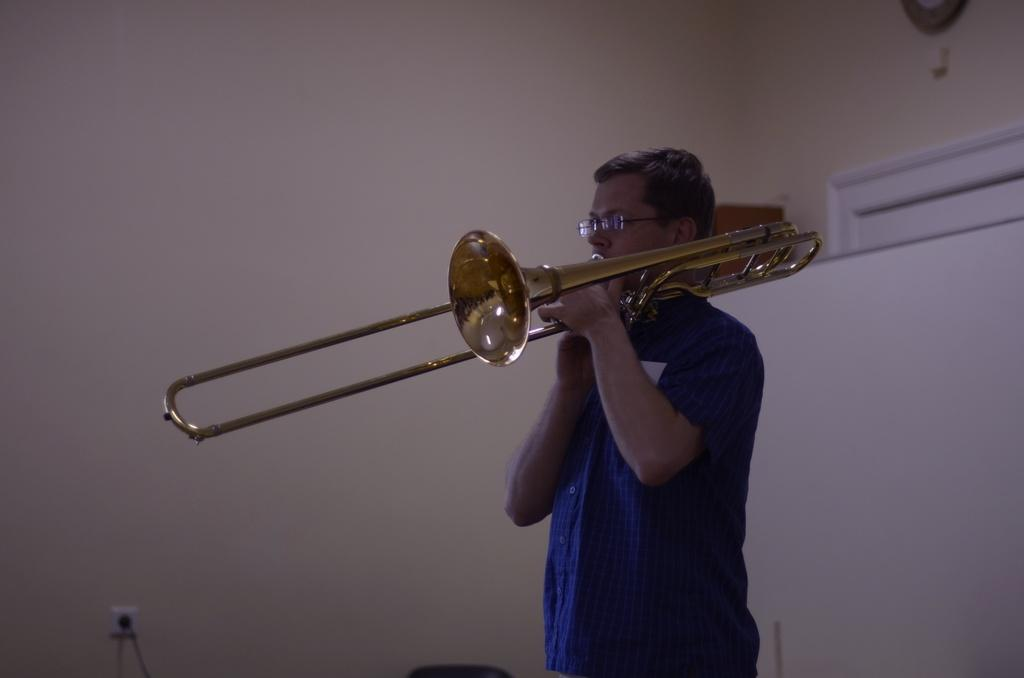What is the person in the image doing? The person is playing a musical instrument in the image. What can be seen behind the person? There is a wall behind the person. Is there anything on the wall in the image? Yes, there is an object on the wall on the right side of the image. What type of blade is being used by the beast in the image? There is no beast or blade present in the image; it features a person playing a musical instrument with a wall and an object on it. 